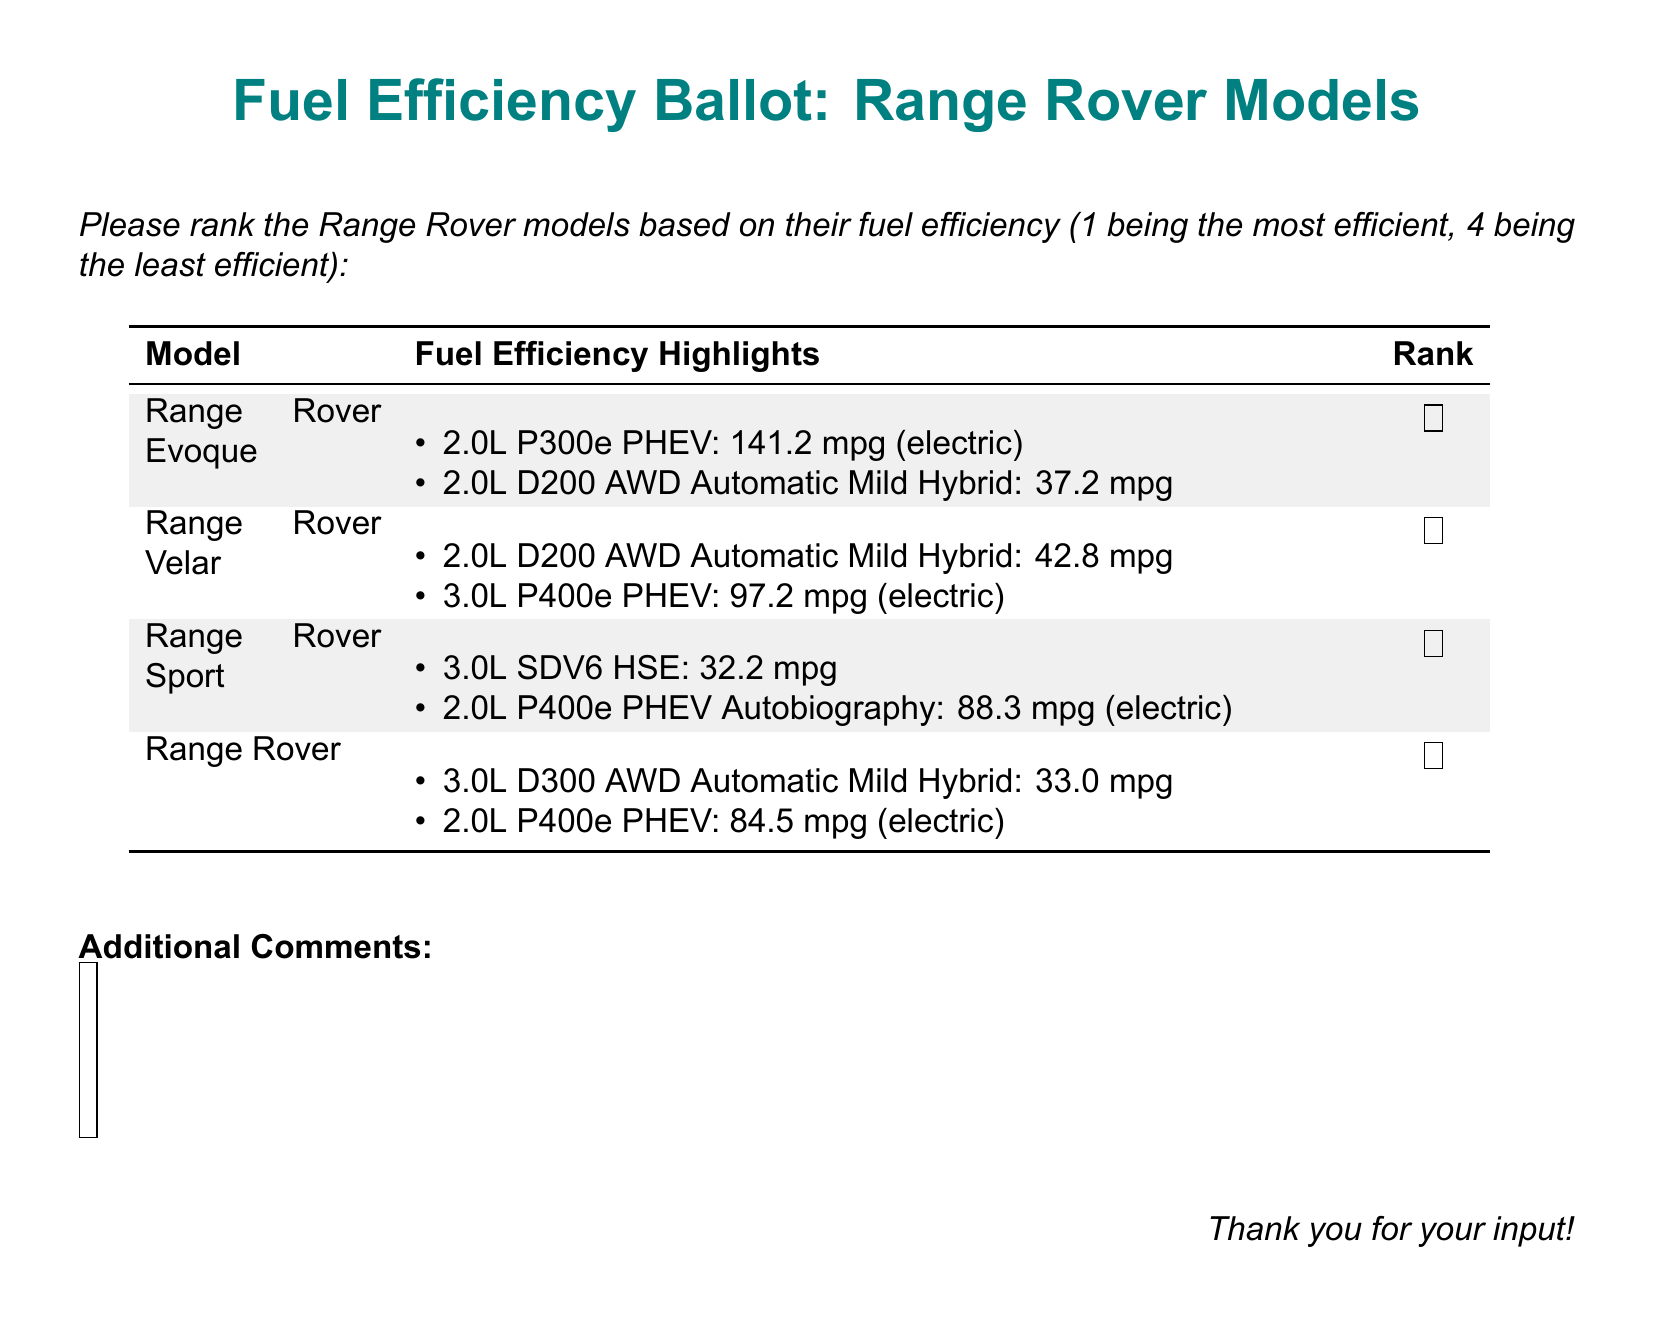What is the most fuel-efficient model? The most fuel-efficient model is determined by the highest mileage listed in the document, which belongs to the Range Rover Evoque with 141.2 mpg (electric).
Answer: Range Rover Evoque What is the fuel efficiency of the Range Rover Velar with the 2.0L D200 AWD Automatic Mild Hybrid? The fuel efficiency for this specific model is provided in the highlights section of the document.
Answer: 42.8 mpg Which model has the lowest fuel efficiency? The lowest fuel efficiency is found in the Range Rover Sport, with a fuel efficiency of 32.2 mpg.
Answer: Range Rover Sport How many Range Rover models are listed in the document? The document contains a total of four different Range Rover models that are highlighted for fuel efficiency.
Answer: Four What is the electric fuel efficiency of the Range Rover Sport PHEV Autobiography? The electric fuel efficiency for this model can be found in the document highlights under Range Rover Sport.
Answer: 88.3 mpg How is the fuel efficiency structured in this ballot? The fuel efficiency highlights of each model are indicated with bullet points detailing different engine types and their respective mileages.
Answer: Bullet points What designation is given to the 2.0L P300e model of the Range Rover Evoque? The designation noted for this model is its PHEV (Plug-in Hybrid Electric Vehicle) status, indicating its electric capabilities.
Answer: PHEV What color highlights the fuel efficiency section of each model? The fuel efficiency highlights for each model alternate in the document, with every other row being light gray.
Answer: Light gray 